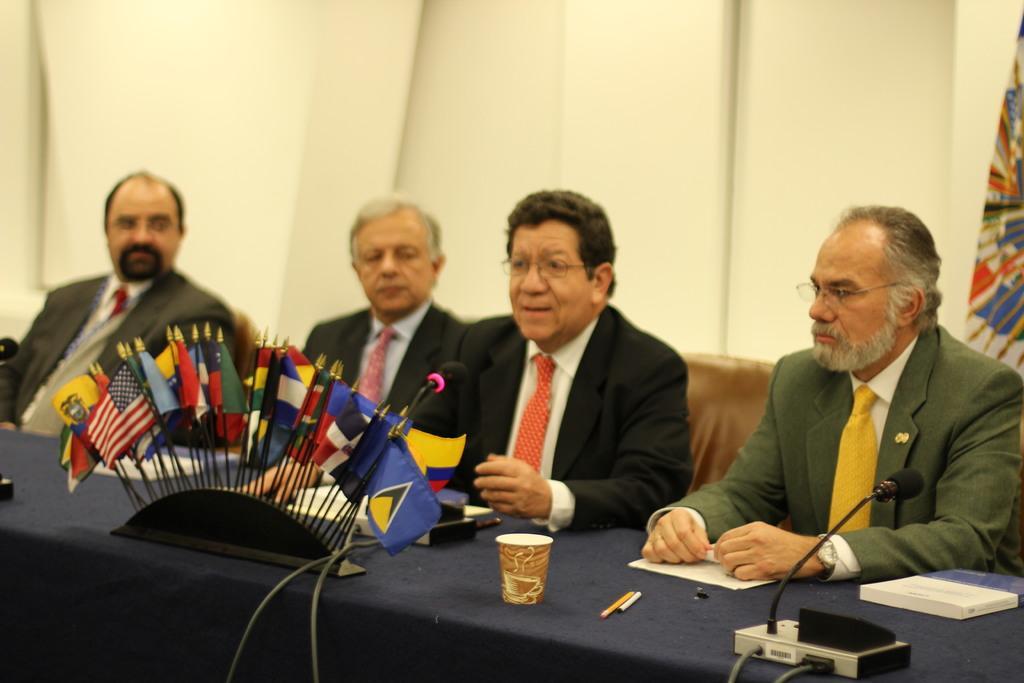How would you summarize this image in a sentence or two? In this picture we can see some men wearing black suit, sitting on the chair and discussing something. In the front there is a blue table with many flags and microphone. In the background we can see a yellow color wall and a flag on the right corner. 